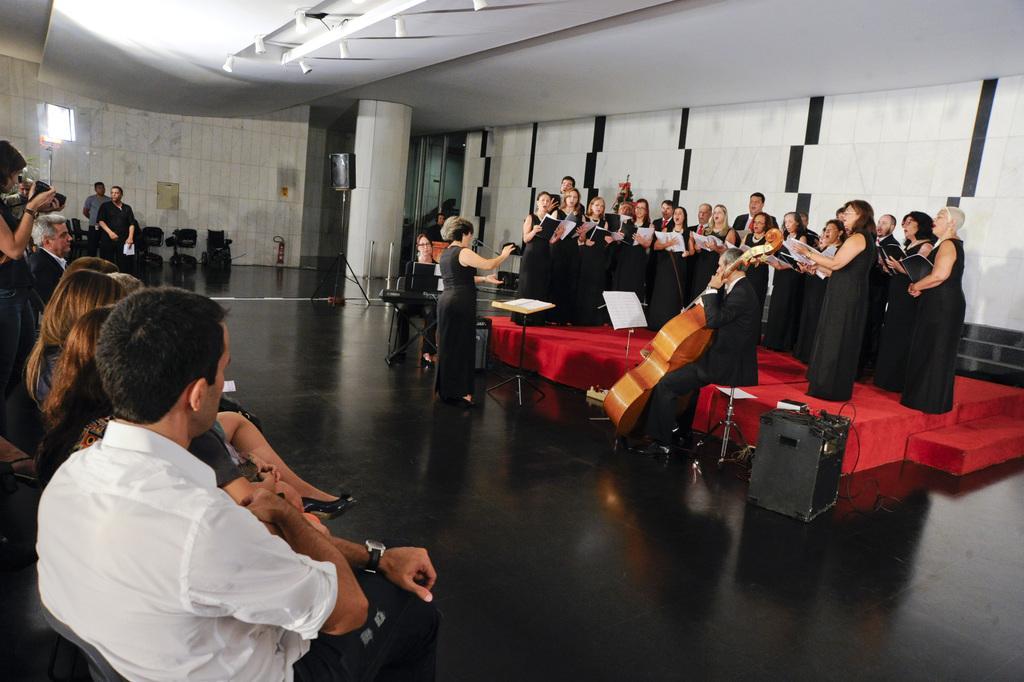Please provide a concise description of this image. In the picture I can see a group of people standing on the stage. They are wearing a black color dress and they are holding a book in their hands. I can see a man holding the guitar and he is sitting on a chair. I can see a few people sitting on the chairs on the left side. There is a woman and she is holding a camera in her hands. I can see the speakers on the floor. 